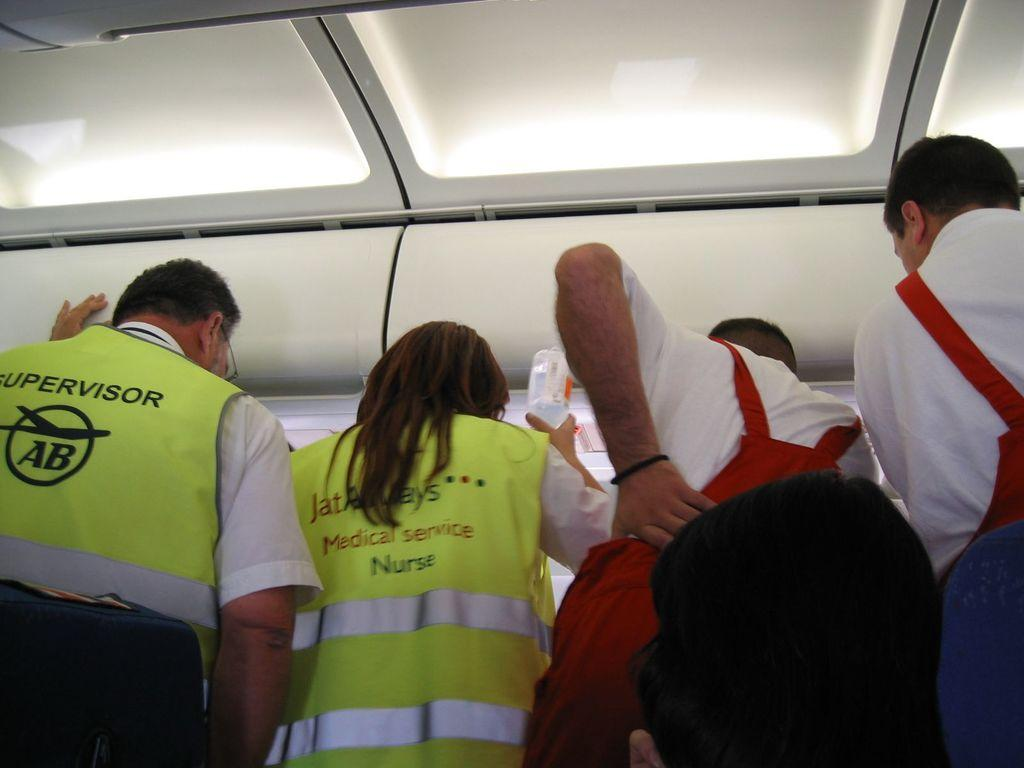How many people are present in the image? There are four people standing in the image. What is the woman holding in the image? The woman is holding a bottle in the image. Where was the image likely taken? The image appears to have been taken inside a vehicle. What type of jar can be seen on the expert's desk in the image? There is no jar or expert present in the image; it features four people standing inside a vehicle. 